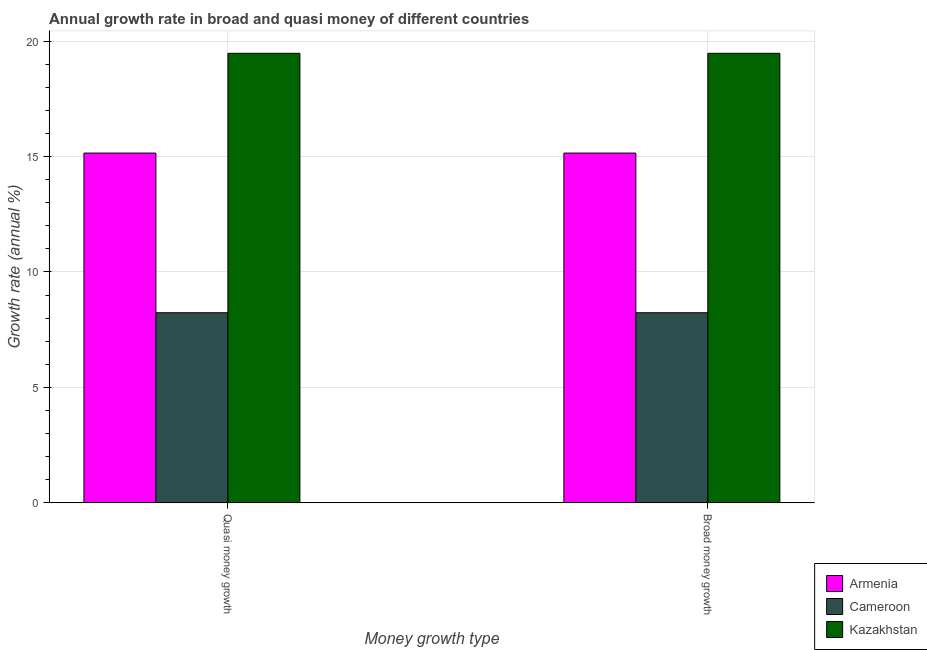How many different coloured bars are there?
Give a very brief answer. 3. Are the number of bars per tick equal to the number of legend labels?
Offer a terse response. Yes. Are the number of bars on each tick of the X-axis equal?
Offer a very short reply. Yes. How many bars are there on the 1st tick from the left?
Keep it short and to the point. 3. How many bars are there on the 2nd tick from the right?
Offer a very short reply. 3. What is the label of the 2nd group of bars from the left?
Offer a terse response. Broad money growth. What is the annual growth rate in quasi money in Cameroon?
Offer a terse response. 8.23. Across all countries, what is the maximum annual growth rate in broad money?
Offer a very short reply. 19.47. Across all countries, what is the minimum annual growth rate in broad money?
Give a very brief answer. 8.23. In which country was the annual growth rate in broad money maximum?
Your answer should be very brief. Kazakhstan. In which country was the annual growth rate in broad money minimum?
Give a very brief answer. Cameroon. What is the total annual growth rate in quasi money in the graph?
Ensure brevity in your answer.  42.85. What is the difference between the annual growth rate in quasi money in Armenia and that in Cameroon?
Offer a very short reply. 6.91. What is the difference between the annual growth rate in quasi money in Cameroon and the annual growth rate in broad money in Armenia?
Offer a very short reply. -6.91. What is the average annual growth rate in quasi money per country?
Your answer should be very brief. 14.28. What is the ratio of the annual growth rate in quasi money in Cameroon to that in Kazakhstan?
Keep it short and to the point. 0.42. In how many countries, is the annual growth rate in quasi money greater than the average annual growth rate in quasi money taken over all countries?
Make the answer very short. 2. What does the 1st bar from the left in Quasi money growth represents?
Make the answer very short. Armenia. What does the 3rd bar from the right in Quasi money growth represents?
Provide a short and direct response. Armenia. Are all the bars in the graph horizontal?
Your answer should be compact. No. How many countries are there in the graph?
Offer a very short reply. 3. What is the difference between two consecutive major ticks on the Y-axis?
Provide a succinct answer. 5. Are the values on the major ticks of Y-axis written in scientific E-notation?
Keep it short and to the point. No. Does the graph contain any zero values?
Offer a terse response. No. Where does the legend appear in the graph?
Provide a short and direct response. Bottom right. What is the title of the graph?
Offer a terse response. Annual growth rate in broad and quasi money of different countries. Does "Yemen, Rep." appear as one of the legend labels in the graph?
Ensure brevity in your answer.  No. What is the label or title of the X-axis?
Your answer should be very brief. Money growth type. What is the label or title of the Y-axis?
Make the answer very short. Growth rate (annual %). What is the Growth rate (annual %) of Armenia in Quasi money growth?
Your response must be concise. 15.15. What is the Growth rate (annual %) in Cameroon in Quasi money growth?
Ensure brevity in your answer.  8.23. What is the Growth rate (annual %) in Kazakhstan in Quasi money growth?
Provide a short and direct response. 19.47. What is the Growth rate (annual %) of Armenia in Broad money growth?
Offer a very short reply. 15.15. What is the Growth rate (annual %) in Cameroon in Broad money growth?
Your response must be concise. 8.23. What is the Growth rate (annual %) of Kazakhstan in Broad money growth?
Your response must be concise. 19.47. Across all Money growth type, what is the maximum Growth rate (annual %) in Armenia?
Your response must be concise. 15.15. Across all Money growth type, what is the maximum Growth rate (annual %) in Cameroon?
Offer a terse response. 8.23. Across all Money growth type, what is the maximum Growth rate (annual %) in Kazakhstan?
Provide a succinct answer. 19.47. Across all Money growth type, what is the minimum Growth rate (annual %) in Armenia?
Provide a succinct answer. 15.15. Across all Money growth type, what is the minimum Growth rate (annual %) in Cameroon?
Give a very brief answer. 8.23. Across all Money growth type, what is the minimum Growth rate (annual %) in Kazakhstan?
Your answer should be very brief. 19.47. What is the total Growth rate (annual %) in Armenia in the graph?
Your response must be concise. 30.29. What is the total Growth rate (annual %) in Cameroon in the graph?
Your response must be concise. 16.46. What is the total Growth rate (annual %) in Kazakhstan in the graph?
Keep it short and to the point. 38.94. What is the difference between the Growth rate (annual %) in Cameroon in Quasi money growth and that in Broad money growth?
Give a very brief answer. 0. What is the difference between the Growth rate (annual %) in Kazakhstan in Quasi money growth and that in Broad money growth?
Offer a very short reply. 0. What is the difference between the Growth rate (annual %) of Armenia in Quasi money growth and the Growth rate (annual %) of Cameroon in Broad money growth?
Make the answer very short. 6.91. What is the difference between the Growth rate (annual %) in Armenia in Quasi money growth and the Growth rate (annual %) in Kazakhstan in Broad money growth?
Your answer should be compact. -4.32. What is the difference between the Growth rate (annual %) in Cameroon in Quasi money growth and the Growth rate (annual %) in Kazakhstan in Broad money growth?
Keep it short and to the point. -11.24. What is the average Growth rate (annual %) of Armenia per Money growth type?
Your answer should be very brief. 15.15. What is the average Growth rate (annual %) in Cameroon per Money growth type?
Make the answer very short. 8.23. What is the average Growth rate (annual %) in Kazakhstan per Money growth type?
Your response must be concise. 19.47. What is the difference between the Growth rate (annual %) in Armenia and Growth rate (annual %) in Cameroon in Quasi money growth?
Keep it short and to the point. 6.91. What is the difference between the Growth rate (annual %) in Armenia and Growth rate (annual %) in Kazakhstan in Quasi money growth?
Offer a terse response. -4.32. What is the difference between the Growth rate (annual %) in Cameroon and Growth rate (annual %) in Kazakhstan in Quasi money growth?
Offer a very short reply. -11.24. What is the difference between the Growth rate (annual %) of Armenia and Growth rate (annual %) of Cameroon in Broad money growth?
Make the answer very short. 6.91. What is the difference between the Growth rate (annual %) of Armenia and Growth rate (annual %) of Kazakhstan in Broad money growth?
Ensure brevity in your answer.  -4.32. What is the difference between the Growth rate (annual %) of Cameroon and Growth rate (annual %) of Kazakhstan in Broad money growth?
Give a very brief answer. -11.24. What is the ratio of the Growth rate (annual %) of Kazakhstan in Quasi money growth to that in Broad money growth?
Your response must be concise. 1. What is the difference between the highest and the second highest Growth rate (annual %) of Armenia?
Keep it short and to the point. 0. What is the difference between the highest and the second highest Growth rate (annual %) in Cameroon?
Offer a terse response. 0. What is the difference between the highest and the lowest Growth rate (annual %) of Armenia?
Offer a very short reply. 0. What is the difference between the highest and the lowest Growth rate (annual %) in Kazakhstan?
Your response must be concise. 0. 